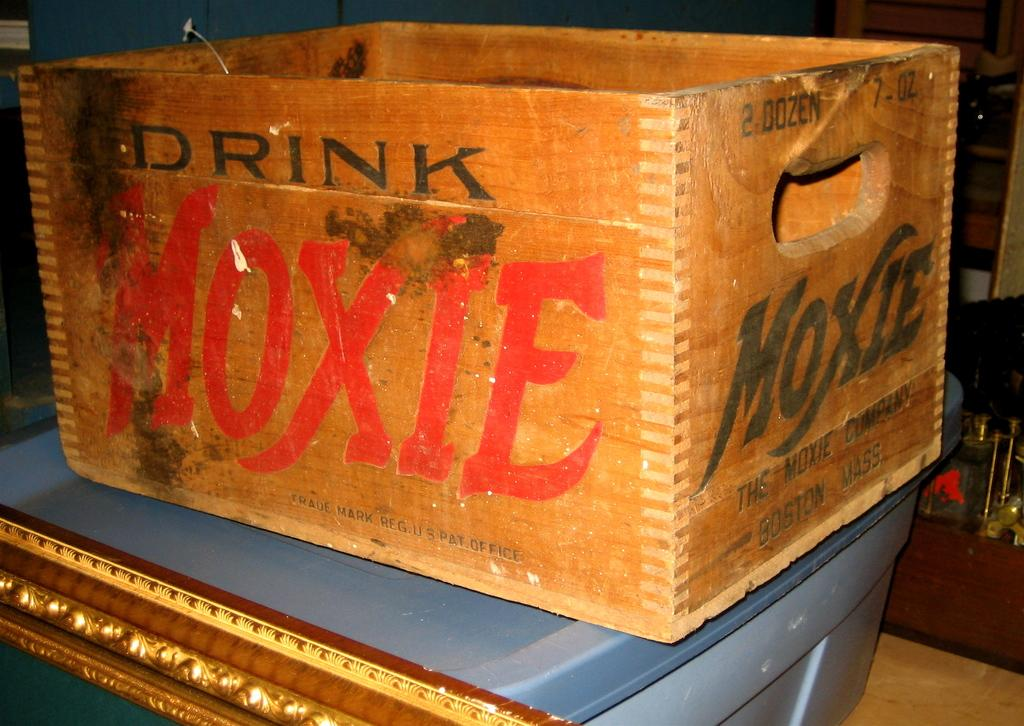<image>
Share a concise interpretation of the image provided. A wooden box has the word moxie on it. 